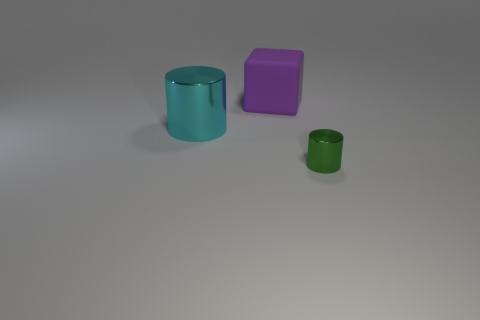There is a shiny cylinder that is left of the green metal thing; is it the same size as the large purple matte thing?
Offer a terse response. Yes. Is there anything else that has the same color as the small cylinder?
Make the answer very short. No. The big cyan shiny thing has what shape?
Give a very brief answer. Cylinder. How many things are both in front of the rubber block and left of the tiny green cylinder?
Your answer should be very brief. 1. Is the color of the large metallic cylinder the same as the small metallic thing?
Ensure brevity in your answer.  No. What is the material of the other object that is the same shape as the green object?
Your answer should be very brief. Metal. Are there any other things that are the same material as the cyan cylinder?
Your answer should be compact. Yes. Are there an equal number of tiny objects that are in front of the big cylinder and tiny green metal things that are left of the large purple matte cube?
Make the answer very short. No. Is the material of the small green cylinder the same as the big purple block?
Make the answer very short. No. How many purple things are shiny objects or big cylinders?
Keep it short and to the point. 0. 